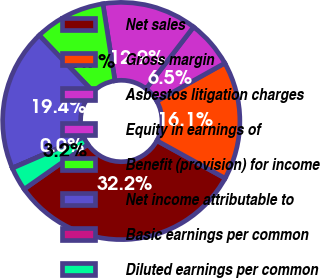Convert chart. <chart><loc_0><loc_0><loc_500><loc_500><pie_chart><fcel>Net sales<fcel>Gross margin<fcel>Asbestos litigation charges<fcel>Equity in earnings of<fcel>Benefit (provision) for income<fcel>Net income attributable to<fcel>Basic earnings per common<fcel>Diluted earnings per common<nl><fcel>32.24%<fcel>16.13%<fcel>6.46%<fcel>12.9%<fcel>9.68%<fcel>19.35%<fcel>0.01%<fcel>3.23%<nl></chart> 